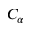Convert formula to latex. <formula><loc_0><loc_0><loc_500><loc_500>C _ { \alpha }</formula> 